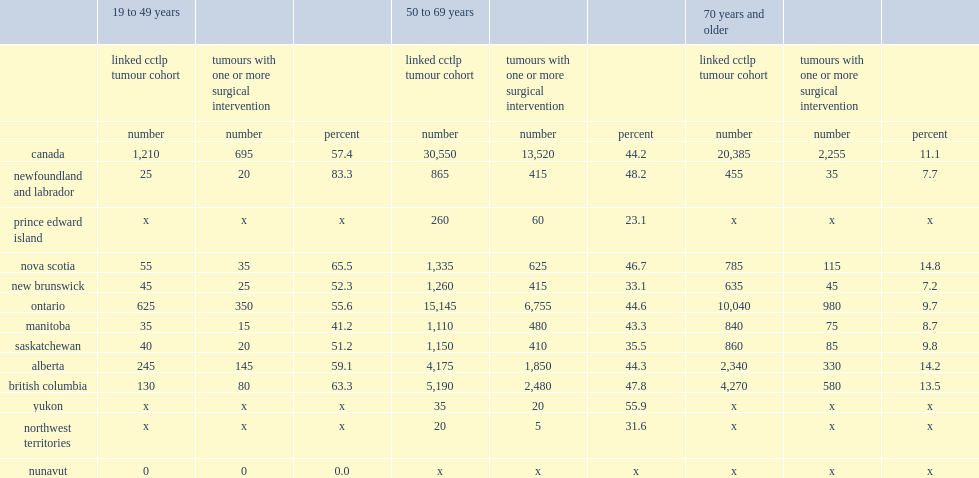In all jurisdictions,which age group has the highest rate of surgical intervention? 19 to 49 years. 